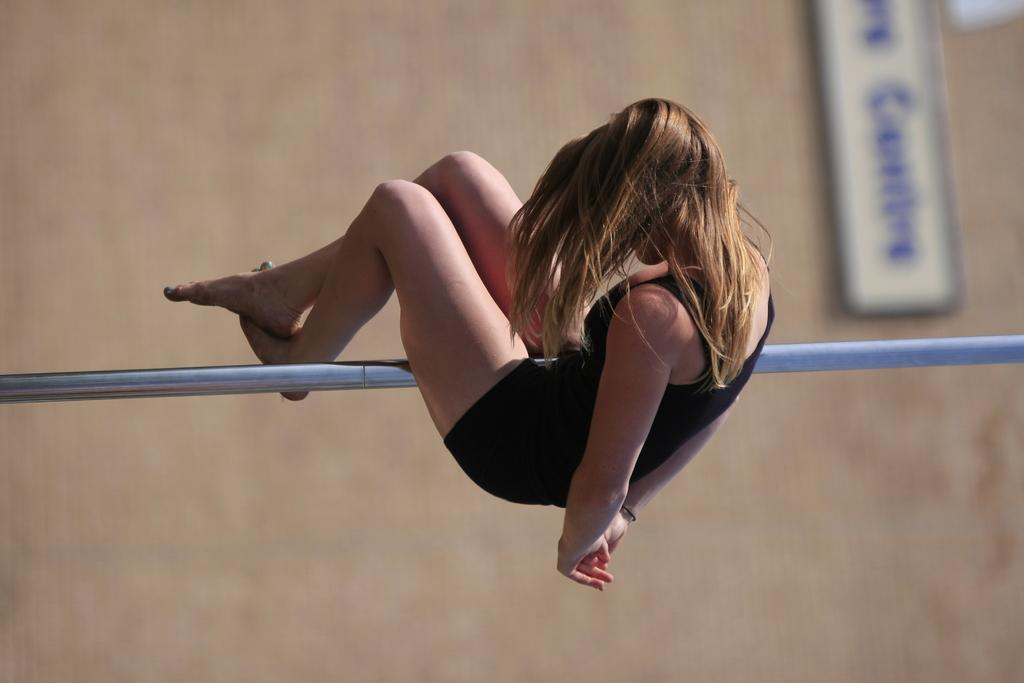Who is the person in the image? There is a woman in the image. What object is present in the image that is typically used for support or display? There is a pole in the image. What can be seen in the background of the image? There is a board in the background of the image. What is the name of the woman in the image? The provided facts do not mention the name of the woman in the image. 